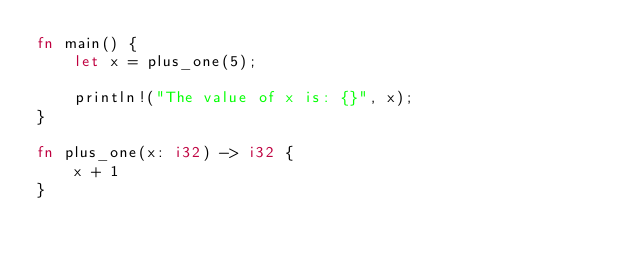Convert code to text. <code><loc_0><loc_0><loc_500><loc_500><_Rust_>fn main() {
    let x = plus_one(5);

    println!("The value of x is: {}", x);
}

fn plus_one(x: i32) -> i32 {
    x + 1
}</code> 